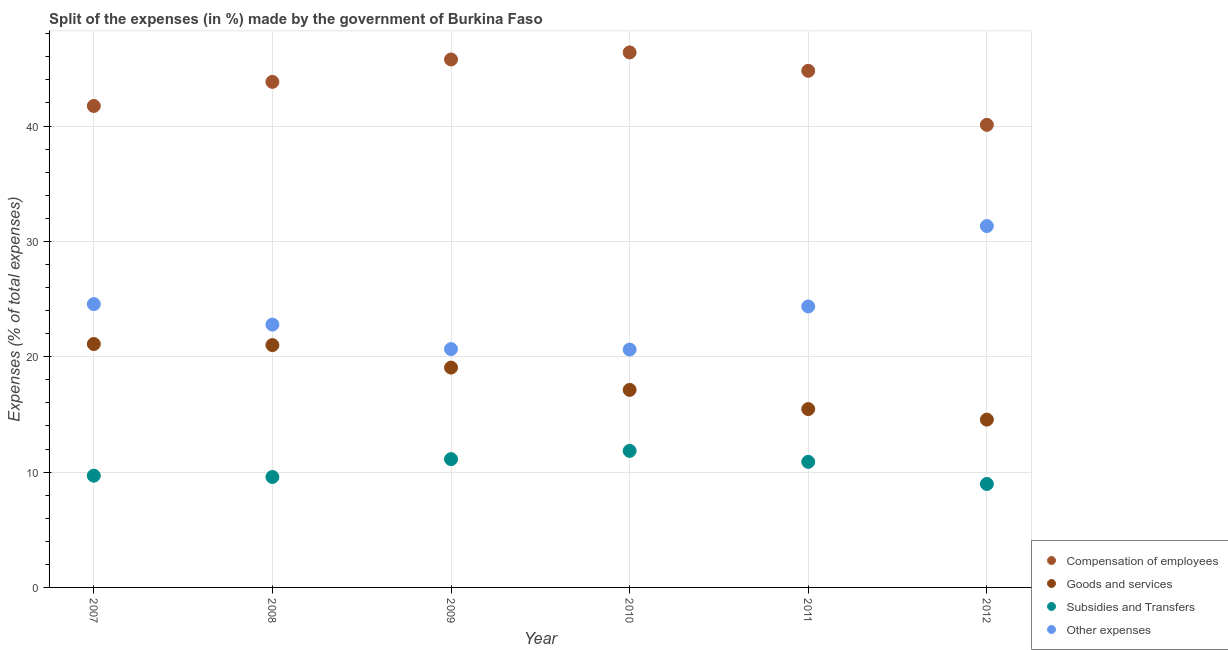Is the number of dotlines equal to the number of legend labels?
Offer a terse response. Yes. What is the percentage of amount spent on subsidies in 2010?
Make the answer very short. 11.84. Across all years, what is the maximum percentage of amount spent on subsidies?
Offer a very short reply. 11.84. Across all years, what is the minimum percentage of amount spent on other expenses?
Offer a terse response. 20.62. What is the total percentage of amount spent on goods and services in the graph?
Offer a very short reply. 108.31. What is the difference between the percentage of amount spent on subsidies in 2007 and that in 2012?
Provide a succinct answer. 0.72. What is the difference between the percentage of amount spent on compensation of employees in 2011 and the percentage of amount spent on goods and services in 2012?
Ensure brevity in your answer.  30.24. What is the average percentage of amount spent on compensation of employees per year?
Give a very brief answer. 43.77. In the year 2010, what is the difference between the percentage of amount spent on other expenses and percentage of amount spent on goods and services?
Offer a very short reply. 3.49. What is the ratio of the percentage of amount spent on goods and services in 2010 to that in 2011?
Give a very brief answer. 1.11. Is the percentage of amount spent on other expenses in 2007 less than that in 2010?
Your response must be concise. No. Is the difference between the percentage of amount spent on compensation of employees in 2008 and 2010 greater than the difference between the percentage of amount spent on goods and services in 2008 and 2010?
Make the answer very short. No. What is the difference between the highest and the second highest percentage of amount spent on other expenses?
Provide a succinct answer. 6.77. What is the difference between the highest and the lowest percentage of amount spent on goods and services?
Your answer should be compact. 6.55. In how many years, is the percentage of amount spent on other expenses greater than the average percentage of amount spent on other expenses taken over all years?
Your answer should be compact. 3. Is it the case that in every year, the sum of the percentage of amount spent on goods and services and percentage of amount spent on subsidies is greater than the sum of percentage of amount spent on other expenses and percentage of amount spent on compensation of employees?
Keep it short and to the point. No. Does the percentage of amount spent on compensation of employees monotonically increase over the years?
Your response must be concise. No. Is the percentage of amount spent on other expenses strictly less than the percentage of amount spent on subsidies over the years?
Give a very brief answer. No. How many years are there in the graph?
Provide a short and direct response. 6. What is the difference between two consecutive major ticks on the Y-axis?
Your answer should be very brief. 10. Does the graph contain any zero values?
Provide a short and direct response. No. Does the graph contain grids?
Offer a very short reply. Yes. How are the legend labels stacked?
Offer a very short reply. Vertical. What is the title of the graph?
Make the answer very short. Split of the expenses (in %) made by the government of Burkina Faso. Does "Finland" appear as one of the legend labels in the graph?
Give a very brief answer. No. What is the label or title of the Y-axis?
Your answer should be compact. Expenses (% of total expenses). What is the Expenses (% of total expenses) in Compensation of employees in 2007?
Ensure brevity in your answer.  41.74. What is the Expenses (% of total expenses) in Goods and services in 2007?
Offer a terse response. 21.1. What is the Expenses (% of total expenses) in Subsidies and Transfers in 2007?
Provide a short and direct response. 9.69. What is the Expenses (% of total expenses) in Other expenses in 2007?
Provide a short and direct response. 24.56. What is the Expenses (% of total expenses) of Compensation of employees in 2008?
Give a very brief answer. 43.83. What is the Expenses (% of total expenses) of Goods and services in 2008?
Make the answer very short. 21.01. What is the Expenses (% of total expenses) of Subsidies and Transfers in 2008?
Your response must be concise. 9.57. What is the Expenses (% of total expenses) of Other expenses in 2008?
Provide a short and direct response. 22.79. What is the Expenses (% of total expenses) in Compensation of employees in 2009?
Offer a very short reply. 45.77. What is the Expenses (% of total expenses) in Goods and services in 2009?
Offer a very short reply. 19.06. What is the Expenses (% of total expenses) of Subsidies and Transfers in 2009?
Make the answer very short. 11.12. What is the Expenses (% of total expenses) of Other expenses in 2009?
Your answer should be very brief. 20.66. What is the Expenses (% of total expenses) of Compensation of employees in 2010?
Your answer should be very brief. 46.38. What is the Expenses (% of total expenses) of Goods and services in 2010?
Ensure brevity in your answer.  17.13. What is the Expenses (% of total expenses) of Subsidies and Transfers in 2010?
Offer a very short reply. 11.84. What is the Expenses (% of total expenses) of Other expenses in 2010?
Make the answer very short. 20.62. What is the Expenses (% of total expenses) in Compensation of employees in 2011?
Give a very brief answer. 44.79. What is the Expenses (% of total expenses) in Goods and services in 2011?
Provide a succinct answer. 15.46. What is the Expenses (% of total expenses) in Subsidies and Transfers in 2011?
Your answer should be very brief. 10.89. What is the Expenses (% of total expenses) of Other expenses in 2011?
Your answer should be very brief. 24.36. What is the Expenses (% of total expenses) of Compensation of employees in 2012?
Offer a terse response. 40.11. What is the Expenses (% of total expenses) of Goods and services in 2012?
Provide a short and direct response. 14.55. What is the Expenses (% of total expenses) of Subsidies and Transfers in 2012?
Give a very brief answer. 8.97. What is the Expenses (% of total expenses) in Other expenses in 2012?
Give a very brief answer. 31.33. Across all years, what is the maximum Expenses (% of total expenses) in Compensation of employees?
Keep it short and to the point. 46.38. Across all years, what is the maximum Expenses (% of total expenses) of Goods and services?
Make the answer very short. 21.1. Across all years, what is the maximum Expenses (% of total expenses) in Subsidies and Transfers?
Give a very brief answer. 11.84. Across all years, what is the maximum Expenses (% of total expenses) of Other expenses?
Provide a short and direct response. 31.33. Across all years, what is the minimum Expenses (% of total expenses) in Compensation of employees?
Provide a succinct answer. 40.11. Across all years, what is the minimum Expenses (% of total expenses) of Goods and services?
Make the answer very short. 14.55. Across all years, what is the minimum Expenses (% of total expenses) in Subsidies and Transfers?
Give a very brief answer. 8.97. Across all years, what is the minimum Expenses (% of total expenses) of Other expenses?
Offer a terse response. 20.62. What is the total Expenses (% of total expenses) of Compensation of employees in the graph?
Offer a very short reply. 262.62. What is the total Expenses (% of total expenses) of Goods and services in the graph?
Provide a short and direct response. 108.31. What is the total Expenses (% of total expenses) in Subsidies and Transfers in the graph?
Offer a very short reply. 62.08. What is the total Expenses (% of total expenses) of Other expenses in the graph?
Give a very brief answer. 144.32. What is the difference between the Expenses (% of total expenses) of Compensation of employees in 2007 and that in 2008?
Keep it short and to the point. -2.09. What is the difference between the Expenses (% of total expenses) in Goods and services in 2007 and that in 2008?
Give a very brief answer. 0.09. What is the difference between the Expenses (% of total expenses) in Subsidies and Transfers in 2007 and that in 2008?
Your answer should be very brief. 0.11. What is the difference between the Expenses (% of total expenses) in Other expenses in 2007 and that in 2008?
Ensure brevity in your answer.  1.77. What is the difference between the Expenses (% of total expenses) in Compensation of employees in 2007 and that in 2009?
Give a very brief answer. -4.03. What is the difference between the Expenses (% of total expenses) in Goods and services in 2007 and that in 2009?
Make the answer very short. 2.04. What is the difference between the Expenses (% of total expenses) in Subsidies and Transfers in 2007 and that in 2009?
Your answer should be very brief. -1.43. What is the difference between the Expenses (% of total expenses) of Other expenses in 2007 and that in 2009?
Keep it short and to the point. 3.9. What is the difference between the Expenses (% of total expenses) of Compensation of employees in 2007 and that in 2010?
Keep it short and to the point. -4.64. What is the difference between the Expenses (% of total expenses) in Goods and services in 2007 and that in 2010?
Offer a very short reply. 3.98. What is the difference between the Expenses (% of total expenses) of Subsidies and Transfers in 2007 and that in 2010?
Your answer should be compact. -2.15. What is the difference between the Expenses (% of total expenses) of Other expenses in 2007 and that in 2010?
Make the answer very short. 3.94. What is the difference between the Expenses (% of total expenses) of Compensation of employees in 2007 and that in 2011?
Your answer should be compact. -3.05. What is the difference between the Expenses (% of total expenses) of Goods and services in 2007 and that in 2011?
Offer a very short reply. 5.64. What is the difference between the Expenses (% of total expenses) in Subsidies and Transfers in 2007 and that in 2011?
Your answer should be very brief. -1.2. What is the difference between the Expenses (% of total expenses) of Other expenses in 2007 and that in 2011?
Offer a terse response. 0.2. What is the difference between the Expenses (% of total expenses) of Compensation of employees in 2007 and that in 2012?
Your answer should be compact. 1.64. What is the difference between the Expenses (% of total expenses) in Goods and services in 2007 and that in 2012?
Your answer should be compact. 6.55. What is the difference between the Expenses (% of total expenses) in Subsidies and Transfers in 2007 and that in 2012?
Provide a short and direct response. 0.72. What is the difference between the Expenses (% of total expenses) of Other expenses in 2007 and that in 2012?
Offer a very short reply. -6.77. What is the difference between the Expenses (% of total expenses) of Compensation of employees in 2008 and that in 2009?
Your answer should be very brief. -1.94. What is the difference between the Expenses (% of total expenses) of Goods and services in 2008 and that in 2009?
Offer a terse response. 1.95. What is the difference between the Expenses (% of total expenses) of Subsidies and Transfers in 2008 and that in 2009?
Your answer should be very brief. -1.55. What is the difference between the Expenses (% of total expenses) of Other expenses in 2008 and that in 2009?
Keep it short and to the point. 2.12. What is the difference between the Expenses (% of total expenses) of Compensation of employees in 2008 and that in 2010?
Your answer should be compact. -2.55. What is the difference between the Expenses (% of total expenses) of Goods and services in 2008 and that in 2010?
Make the answer very short. 3.88. What is the difference between the Expenses (% of total expenses) in Subsidies and Transfers in 2008 and that in 2010?
Ensure brevity in your answer.  -2.26. What is the difference between the Expenses (% of total expenses) in Other expenses in 2008 and that in 2010?
Ensure brevity in your answer.  2.17. What is the difference between the Expenses (% of total expenses) of Compensation of employees in 2008 and that in 2011?
Your answer should be very brief. -0.96. What is the difference between the Expenses (% of total expenses) in Goods and services in 2008 and that in 2011?
Ensure brevity in your answer.  5.55. What is the difference between the Expenses (% of total expenses) of Subsidies and Transfers in 2008 and that in 2011?
Your answer should be very brief. -1.31. What is the difference between the Expenses (% of total expenses) of Other expenses in 2008 and that in 2011?
Provide a short and direct response. -1.57. What is the difference between the Expenses (% of total expenses) in Compensation of employees in 2008 and that in 2012?
Provide a succinct answer. 3.72. What is the difference between the Expenses (% of total expenses) in Goods and services in 2008 and that in 2012?
Your answer should be very brief. 6.46. What is the difference between the Expenses (% of total expenses) of Subsidies and Transfers in 2008 and that in 2012?
Your answer should be very brief. 0.61. What is the difference between the Expenses (% of total expenses) of Other expenses in 2008 and that in 2012?
Your answer should be very brief. -8.54. What is the difference between the Expenses (% of total expenses) in Compensation of employees in 2009 and that in 2010?
Your answer should be very brief. -0.61. What is the difference between the Expenses (% of total expenses) of Goods and services in 2009 and that in 2010?
Offer a very short reply. 1.93. What is the difference between the Expenses (% of total expenses) in Subsidies and Transfers in 2009 and that in 2010?
Your answer should be compact. -0.71. What is the difference between the Expenses (% of total expenses) in Other expenses in 2009 and that in 2010?
Ensure brevity in your answer.  0.04. What is the difference between the Expenses (% of total expenses) in Compensation of employees in 2009 and that in 2011?
Provide a succinct answer. 0.98. What is the difference between the Expenses (% of total expenses) of Goods and services in 2009 and that in 2011?
Ensure brevity in your answer.  3.6. What is the difference between the Expenses (% of total expenses) in Subsidies and Transfers in 2009 and that in 2011?
Give a very brief answer. 0.24. What is the difference between the Expenses (% of total expenses) in Other expenses in 2009 and that in 2011?
Ensure brevity in your answer.  -3.69. What is the difference between the Expenses (% of total expenses) of Compensation of employees in 2009 and that in 2012?
Offer a very short reply. 5.67. What is the difference between the Expenses (% of total expenses) of Goods and services in 2009 and that in 2012?
Provide a succinct answer. 4.51. What is the difference between the Expenses (% of total expenses) in Subsidies and Transfers in 2009 and that in 2012?
Provide a short and direct response. 2.15. What is the difference between the Expenses (% of total expenses) of Other expenses in 2009 and that in 2012?
Keep it short and to the point. -10.67. What is the difference between the Expenses (% of total expenses) of Compensation of employees in 2010 and that in 2011?
Provide a short and direct response. 1.6. What is the difference between the Expenses (% of total expenses) of Goods and services in 2010 and that in 2011?
Keep it short and to the point. 1.66. What is the difference between the Expenses (% of total expenses) of Subsidies and Transfers in 2010 and that in 2011?
Your answer should be very brief. 0.95. What is the difference between the Expenses (% of total expenses) in Other expenses in 2010 and that in 2011?
Provide a succinct answer. -3.74. What is the difference between the Expenses (% of total expenses) in Compensation of employees in 2010 and that in 2012?
Keep it short and to the point. 6.28. What is the difference between the Expenses (% of total expenses) in Goods and services in 2010 and that in 2012?
Your answer should be very brief. 2.58. What is the difference between the Expenses (% of total expenses) in Subsidies and Transfers in 2010 and that in 2012?
Keep it short and to the point. 2.87. What is the difference between the Expenses (% of total expenses) in Other expenses in 2010 and that in 2012?
Keep it short and to the point. -10.71. What is the difference between the Expenses (% of total expenses) in Compensation of employees in 2011 and that in 2012?
Give a very brief answer. 4.68. What is the difference between the Expenses (% of total expenses) in Goods and services in 2011 and that in 2012?
Offer a terse response. 0.91. What is the difference between the Expenses (% of total expenses) in Subsidies and Transfers in 2011 and that in 2012?
Ensure brevity in your answer.  1.92. What is the difference between the Expenses (% of total expenses) of Other expenses in 2011 and that in 2012?
Offer a very short reply. -6.97. What is the difference between the Expenses (% of total expenses) in Compensation of employees in 2007 and the Expenses (% of total expenses) in Goods and services in 2008?
Provide a succinct answer. 20.73. What is the difference between the Expenses (% of total expenses) of Compensation of employees in 2007 and the Expenses (% of total expenses) of Subsidies and Transfers in 2008?
Provide a succinct answer. 32.17. What is the difference between the Expenses (% of total expenses) in Compensation of employees in 2007 and the Expenses (% of total expenses) in Other expenses in 2008?
Offer a terse response. 18.95. What is the difference between the Expenses (% of total expenses) in Goods and services in 2007 and the Expenses (% of total expenses) in Subsidies and Transfers in 2008?
Your answer should be very brief. 11.53. What is the difference between the Expenses (% of total expenses) in Goods and services in 2007 and the Expenses (% of total expenses) in Other expenses in 2008?
Provide a succinct answer. -1.69. What is the difference between the Expenses (% of total expenses) of Subsidies and Transfers in 2007 and the Expenses (% of total expenses) of Other expenses in 2008?
Offer a terse response. -13.1. What is the difference between the Expenses (% of total expenses) in Compensation of employees in 2007 and the Expenses (% of total expenses) in Goods and services in 2009?
Your answer should be compact. 22.68. What is the difference between the Expenses (% of total expenses) of Compensation of employees in 2007 and the Expenses (% of total expenses) of Subsidies and Transfers in 2009?
Make the answer very short. 30.62. What is the difference between the Expenses (% of total expenses) in Compensation of employees in 2007 and the Expenses (% of total expenses) in Other expenses in 2009?
Ensure brevity in your answer.  21.08. What is the difference between the Expenses (% of total expenses) in Goods and services in 2007 and the Expenses (% of total expenses) in Subsidies and Transfers in 2009?
Make the answer very short. 9.98. What is the difference between the Expenses (% of total expenses) of Goods and services in 2007 and the Expenses (% of total expenses) of Other expenses in 2009?
Make the answer very short. 0.44. What is the difference between the Expenses (% of total expenses) of Subsidies and Transfers in 2007 and the Expenses (% of total expenses) of Other expenses in 2009?
Provide a succinct answer. -10.98. What is the difference between the Expenses (% of total expenses) in Compensation of employees in 2007 and the Expenses (% of total expenses) in Goods and services in 2010?
Offer a terse response. 24.62. What is the difference between the Expenses (% of total expenses) of Compensation of employees in 2007 and the Expenses (% of total expenses) of Subsidies and Transfers in 2010?
Your response must be concise. 29.9. What is the difference between the Expenses (% of total expenses) in Compensation of employees in 2007 and the Expenses (% of total expenses) in Other expenses in 2010?
Keep it short and to the point. 21.12. What is the difference between the Expenses (% of total expenses) of Goods and services in 2007 and the Expenses (% of total expenses) of Subsidies and Transfers in 2010?
Your response must be concise. 9.26. What is the difference between the Expenses (% of total expenses) of Goods and services in 2007 and the Expenses (% of total expenses) of Other expenses in 2010?
Provide a succinct answer. 0.48. What is the difference between the Expenses (% of total expenses) in Subsidies and Transfers in 2007 and the Expenses (% of total expenses) in Other expenses in 2010?
Give a very brief answer. -10.93. What is the difference between the Expenses (% of total expenses) of Compensation of employees in 2007 and the Expenses (% of total expenses) of Goods and services in 2011?
Your response must be concise. 26.28. What is the difference between the Expenses (% of total expenses) in Compensation of employees in 2007 and the Expenses (% of total expenses) in Subsidies and Transfers in 2011?
Provide a succinct answer. 30.86. What is the difference between the Expenses (% of total expenses) in Compensation of employees in 2007 and the Expenses (% of total expenses) in Other expenses in 2011?
Your answer should be compact. 17.38. What is the difference between the Expenses (% of total expenses) in Goods and services in 2007 and the Expenses (% of total expenses) in Subsidies and Transfers in 2011?
Ensure brevity in your answer.  10.22. What is the difference between the Expenses (% of total expenses) of Goods and services in 2007 and the Expenses (% of total expenses) of Other expenses in 2011?
Offer a terse response. -3.26. What is the difference between the Expenses (% of total expenses) in Subsidies and Transfers in 2007 and the Expenses (% of total expenses) in Other expenses in 2011?
Give a very brief answer. -14.67. What is the difference between the Expenses (% of total expenses) of Compensation of employees in 2007 and the Expenses (% of total expenses) of Goods and services in 2012?
Offer a terse response. 27.19. What is the difference between the Expenses (% of total expenses) in Compensation of employees in 2007 and the Expenses (% of total expenses) in Subsidies and Transfers in 2012?
Ensure brevity in your answer.  32.77. What is the difference between the Expenses (% of total expenses) of Compensation of employees in 2007 and the Expenses (% of total expenses) of Other expenses in 2012?
Your answer should be compact. 10.41. What is the difference between the Expenses (% of total expenses) of Goods and services in 2007 and the Expenses (% of total expenses) of Subsidies and Transfers in 2012?
Make the answer very short. 12.13. What is the difference between the Expenses (% of total expenses) in Goods and services in 2007 and the Expenses (% of total expenses) in Other expenses in 2012?
Provide a succinct answer. -10.23. What is the difference between the Expenses (% of total expenses) of Subsidies and Transfers in 2007 and the Expenses (% of total expenses) of Other expenses in 2012?
Ensure brevity in your answer.  -21.64. What is the difference between the Expenses (% of total expenses) in Compensation of employees in 2008 and the Expenses (% of total expenses) in Goods and services in 2009?
Offer a terse response. 24.77. What is the difference between the Expenses (% of total expenses) in Compensation of employees in 2008 and the Expenses (% of total expenses) in Subsidies and Transfers in 2009?
Provide a succinct answer. 32.71. What is the difference between the Expenses (% of total expenses) in Compensation of employees in 2008 and the Expenses (% of total expenses) in Other expenses in 2009?
Provide a succinct answer. 23.16. What is the difference between the Expenses (% of total expenses) in Goods and services in 2008 and the Expenses (% of total expenses) in Subsidies and Transfers in 2009?
Your answer should be compact. 9.89. What is the difference between the Expenses (% of total expenses) of Goods and services in 2008 and the Expenses (% of total expenses) of Other expenses in 2009?
Your response must be concise. 0.35. What is the difference between the Expenses (% of total expenses) of Subsidies and Transfers in 2008 and the Expenses (% of total expenses) of Other expenses in 2009?
Give a very brief answer. -11.09. What is the difference between the Expenses (% of total expenses) in Compensation of employees in 2008 and the Expenses (% of total expenses) in Goods and services in 2010?
Offer a very short reply. 26.7. What is the difference between the Expenses (% of total expenses) in Compensation of employees in 2008 and the Expenses (% of total expenses) in Subsidies and Transfers in 2010?
Give a very brief answer. 31.99. What is the difference between the Expenses (% of total expenses) of Compensation of employees in 2008 and the Expenses (% of total expenses) of Other expenses in 2010?
Make the answer very short. 23.21. What is the difference between the Expenses (% of total expenses) of Goods and services in 2008 and the Expenses (% of total expenses) of Subsidies and Transfers in 2010?
Provide a succinct answer. 9.17. What is the difference between the Expenses (% of total expenses) of Goods and services in 2008 and the Expenses (% of total expenses) of Other expenses in 2010?
Your response must be concise. 0.39. What is the difference between the Expenses (% of total expenses) in Subsidies and Transfers in 2008 and the Expenses (% of total expenses) in Other expenses in 2010?
Give a very brief answer. -11.05. What is the difference between the Expenses (% of total expenses) of Compensation of employees in 2008 and the Expenses (% of total expenses) of Goods and services in 2011?
Make the answer very short. 28.37. What is the difference between the Expenses (% of total expenses) in Compensation of employees in 2008 and the Expenses (% of total expenses) in Subsidies and Transfers in 2011?
Keep it short and to the point. 32.94. What is the difference between the Expenses (% of total expenses) of Compensation of employees in 2008 and the Expenses (% of total expenses) of Other expenses in 2011?
Give a very brief answer. 19.47. What is the difference between the Expenses (% of total expenses) in Goods and services in 2008 and the Expenses (% of total expenses) in Subsidies and Transfers in 2011?
Provide a succinct answer. 10.12. What is the difference between the Expenses (% of total expenses) of Goods and services in 2008 and the Expenses (% of total expenses) of Other expenses in 2011?
Make the answer very short. -3.35. What is the difference between the Expenses (% of total expenses) of Subsidies and Transfers in 2008 and the Expenses (% of total expenses) of Other expenses in 2011?
Your answer should be very brief. -14.78. What is the difference between the Expenses (% of total expenses) in Compensation of employees in 2008 and the Expenses (% of total expenses) in Goods and services in 2012?
Offer a terse response. 29.28. What is the difference between the Expenses (% of total expenses) of Compensation of employees in 2008 and the Expenses (% of total expenses) of Subsidies and Transfers in 2012?
Give a very brief answer. 34.86. What is the difference between the Expenses (% of total expenses) in Compensation of employees in 2008 and the Expenses (% of total expenses) in Other expenses in 2012?
Ensure brevity in your answer.  12.5. What is the difference between the Expenses (% of total expenses) in Goods and services in 2008 and the Expenses (% of total expenses) in Subsidies and Transfers in 2012?
Make the answer very short. 12.04. What is the difference between the Expenses (% of total expenses) in Goods and services in 2008 and the Expenses (% of total expenses) in Other expenses in 2012?
Offer a terse response. -10.32. What is the difference between the Expenses (% of total expenses) of Subsidies and Transfers in 2008 and the Expenses (% of total expenses) of Other expenses in 2012?
Make the answer very short. -21.76. What is the difference between the Expenses (% of total expenses) in Compensation of employees in 2009 and the Expenses (% of total expenses) in Goods and services in 2010?
Your answer should be compact. 28.65. What is the difference between the Expenses (% of total expenses) in Compensation of employees in 2009 and the Expenses (% of total expenses) in Subsidies and Transfers in 2010?
Ensure brevity in your answer.  33.93. What is the difference between the Expenses (% of total expenses) in Compensation of employees in 2009 and the Expenses (% of total expenses) in Other expenses in 2010?
Your response must be concise. 25.15. What is the difference between the Expenses (% of total expenses) in Goods and services in 2009 and the Expenses (% of total expenses) in Subsidies and Transfers in 2010?
Provide a succinct answer. 7.22. What is the difference between the Expenses (% of total expenses) of Goods and services in 2009 and the Expenses (% of total expenses) of Other expenses in 2010?
Keep it short and to the point. -1.56. What is the difference between the Expenses (% of total expenses) in Subsidies and Transfers in 2009 and the Expenses (% of total expenses) in Other expenses in 2010?
Offer a terse response. -9.5. What is the difference between the Expenses (% of total expenses) in Compensation of employees in 2009 and the Expenses (% of total expenses) in Goods and services in 2011?
Keep it short and to the point. 30.31. What is the difference between the Expenses (% of total expenses) in Compensation of employees in 2009 and the Expenses (% of total expenses) in Subsidies and Transfers in 2011?
Keep it short and to the point. 34.89. What is the difference between the Expenses (% of total expenses) in Compensation of employees in 2009 and the Expenses (% of total expenses) in Other expenses in 2011?
Make the answer very short. 21.41. What is the difference between the Expenses (% of total expenses) of Goods and services in 2009 and the Expenses (% of total expenses) of Subsidies and Transfers in 2011?
Provide a short and direct response. 8.17. What is the difference between the Expenses (% of total expenses) in Goods and services in 2009 and the Expenses (% of total expenses) in Other expenses in 2011?
Provide a succinct answer. -5.3. What is the difference between the Expenses (% of total expenses) in Subsidies and Transfers in 2009 and the Expenses (% of total expenses) in Other expenses in 2011?
Your response must be concise. -13.24. What is the difference between the Expenses (% of total expenses) of Compensation of employees in 2009 and the Expenses (% of total expenses) of Goods and services in 2012?
Ensure brevity in your answer.  31.22. What is the difference between the Expenses (% of total expenses) in Compensation of employees in 2009 and the Expenses (% of total expenses) in Subsidies and Transfers in 2012?
Give a very brief answer. 36.8. What is the difference between the Expenses (% of total expenses) of Compensation of employees in 2009 and the Expenses (% of total expenses) of Other expenses in 2012?
Offer a terse response. 14.44. What is the difference between the Expenses (% of total expenses) of Goods and services in 2009 and the Expenses (% of total expenses) of Subsidies and Transfers in 2012?
Provide a succinct answer. 10.09. What is the difference between the Expenses (% of total expenses) in Goods and services in 2009 and the Expenses (% of total expenses) in Other expenses in 2012?
Make the answer very short. -12.27. What is the difference between the Expenses (% of total expenses) of Subsidies and Transfers in 2009 and the Expenses (% of total expenses) of Other expenses in 2012?
Keep it short and to the point. -20.21. What is the difference between the Expenses (% of total expenses) of Compensation of employees in 2010 and the Expenses (% of total expenses) of Goods and services in 2011?
Make the answer very short. 30.92. What is the difference between the Expenses (% of total expenses) of Compensation of employees in 2010 and the Expenses (% of total expenses) of Subsidies and Transfers in 2011?
Provide a short and direct response. 35.5. What is the difference between the Expenses (% of total expenses) in Compensation of employees in 2010 and the Expenses (% of total expenses) in Other expenses in 2011?
Your answer should be very brief. 22.03. What is the difference between the Expenses (% of total expenses) of Goods and services in 2010 and the Expenses (% of total expenses) of Subsidies and Transfers in 2011?
Your answer should be very brief. 6.24. What is the difference between the Expenses (% of total expenses) of Goods and services in 2010 and the Expenses (% of total expenses) of Other expenses in 2011?
Give a very brief answer. -7.23. What is the difference between the Expenses (% of total expenses) of Subsidies and Transfers in 2010 and the Expenses (% of total expenses) of Other expenses in 2011?
Keep it short and to the point. -12.52. What is the difference between the Expenses (% of total expenses) of Compensation of employees in 2010 and the Expenses (% of total expenses) of Goods and services in 2012?
Make the answer very short. 31.83. What is the difference between the Expenses (% of total expenses) in Compensation of employees in 2010 and the Expenses (% of total expenses) in Subsidies and Transfers in 2012?
Provide a short and direct response. 37.42. What is the difference between the Expenses (% of total expenses) in Compensation of employees in 2010 and the Expenses (% of total expenses) in Other expenses in 2012?
Your response must be concise. 15.05. What is the difference between the Expenses (% of total expenses) of Goods and services in 2010 and the Expenses (% of total expenses) of Subsidies and Transfers in 2012?
Keep it short and to the point. 8.16. What is the difference between the Expenses (% of total expenses) in Goods and services in 2010 and the Expenses (% of total expenses) in Other expenses in 2012?
Offer a terse response. -14.2. What is the difference between the Expenses (% of total expenses) in Subsidies and Transfers in 2010 and the Expenses (% of total expenses) in Other expenses in 2012?
Offer a terse response. -19.49. What is the difference between the Expenses (% of total expenses) in Compensation of employees in 2011 and the Expenses (% of total expenses) in Goods and services in 2012?
Your answer should be compact. 30.24. What is the difference between the Expenses (% of total expenses) in Compensation of employees in 2011 and the Expenses (% of total expenses) in Subsidies and Transfers in 2012?
Offer a very short reply. 35.82. What is the difference between the Expenses (% of total expenses) of Compensation of employees in 2011 and the Expenses (% of total expenses) of Other expenses in 2012?
Provide a succinct answer. 13.46. What is the difference between the Expenses (% of total expenses) of Goods and services in 2011 and the Expenses (% of total expenses) of Subsidies and Transfers in 2012?
Keep it short and to the point. 6.49. What is the difference between the Expenses (% of total expenses) in Goods and services in 2011 and the Expenses (% of total expenses) in Other expenses in 2012?
Your response must be concise. -15.87. What is the difference between the Expenses (% of total expenses) in Subsidies and Transfers in 2011 and the Expenses (% of total expenses) in Other expenses in 2012?
Ensure brevity in your answer.  -20.44. What is the average Expenses (% of total expenses) in Compensation of employees per year?
Provide a succinct answer. 43.77. What is the average Expenses (% of total expenses) of Goods and services per year?
Give a very brief answer. 18.05. What is the average Expenses (% of total expenses) in Subsidies and Transfers per year?
Keep it short and to the point. 10.35. What is the average Expenses (% of total expenses) in Other expenses per year?
Provide a succinct answer. 24.05. In the year 2007, what is the difference between the Expenses (% of total expenses) of Compensation of employees and Expenses (% of total expenses) of Goods and services?
Your answer should be compact. 20.64. In the year 2007, what is the difference between the Expenses (% of total expenses) of Compensation of employees and Expenses (% of total expenses) of Subsidies and Transfers?
Make the answer very short. 32.05. In the year 2007, what is the difference between the Expenses (% of total expenses) in Compensation of employees and Expenses (% of total expenses) in Other expenses?
Your answer should be compact. 17.18. In the year 2007, what is the difference between the Expenses (% of total expenses) in Goods and services and Expenses (% of total expenses) in Subsidies and Transfers?
Give a very brief answer. 11.41. In the year 2007, what is the difference between the Expenses (% of total expenses) in Goods and services and Expenses (% of total expenses) in Other expenses?
Provide a short and direct response. -3.46. In the year 2007, what is the difference between the Expenses (% of total expenses) of Subsidies and Transfers and Expenses (% of total expenses) of Other expenses?
Your answer should be very brief. -14.87. In the year 2008, what is the difference between the Expenses (% of total expenses) of Compensation of employees and Expenses (% of total expenses) of Goods and services?
Keep it short and to the point. 22.82. In the year 2008, what is the difference between the Expenses (% of total expenses) of Compensation of employees and Expenses (% of total expenses) of Subsidies and Transfers?
Your answer should be compact. 34.26. In the year 2008, what is the difference between the Expenses (% of total expenses) of Compensation of employees and Expenses (% of total expenses) of Other expenses?
Keep it short and to the point. 21.04. In the year 2008, what is the difference between the Expenses (% of total expenses) in Goods and services and Expenses (% of total expenses) in Subsidies and Transfers?
Your answer should be compact. 11.44. In the year 2008, what is the difference between the Expenses (% of total expenses) in Goods and services and Expenses (% of total expenses) in Other expenses?
Provide a succinct answer. -1.78. In the year 2008, what is the difference between the Expenses (% of total expenses) of Subsidies and Transfers and Expenses (% of total expenses) of Other expenses?
Offer a terse response. -13.21. In the year 2009, what is the difference between the Expenses (% of total expenses) in Compensation of employees and Expenses (% of total expenses) in Goods and services?
Give a very brief answer. 26.71. In the year 2009, what is the difference between the Expenses (% of total expenses) in Compensation of employees and Expenses (% of total expenses) in Subsidies and Transfers?
Offer a terse response. 34.65. In the year 2009, what is the difference between the Expenses (% of total expenses) of Compensation of employees and Expenses (% of total expenses) of Other expenses?
Give a very brief answer. 25.11. In the year 2009, what is the difference between the Expenses (% of total expenses) in Goods and services and Expenses (% of total expenses) in Subsidies and Transfers?
Your answer should be compact. 7.94. In the year 2009, what is the difference between the Expenses (% of total expenses) of Goods and services and Expenses (% of total expenses) of Other expenses?
Ensure brevity in your answer.  -1.61. In the year 2009, what is the difference between the Expenses (% of total expenses) of Subsidies and Transfers and Expenses (% of total expenses) of Other expenses?
Give a very brief answer. -9.54. In the year 2010, what is the difference between the Expenses (% of total expenses) of Compensation of employees and Expenses (% of total expenses) of Goods and services?
Provide a succinct answer. 29.26. In the year 2010, what is the difference between the Expenses (% of total expenses) of Compensation of employees and Expenses (% of total expenses) of Subsidies and Transfers?
Your response must be concise. 34.55. In the year 2010, what is the difference between the Expenses (% of total expenses) of Compensation of employees and Expenses (% of total expenses) of Other expenses?
Your answer should be compact. 25.76. In the year 2010, what is the difference between the Expenses (% of total expenses) in Goods and services and Expenses (% of total expenses) in Subsidies and Transfers?
Make the answer very short. 5.29. In the year 2010, what is the difference between the Expenses (% of total expenses) of Goods and services and Expenses (% of total expenses) of Other expenses?
Give a very brief answer. -3.49. In the year 2010, what is the difference between the Expenses (% of total expenses) of Subsidies and Transfers and Expenses (% of total expenses) of Other expenses?
Provide a short and direct response. -8.78. In the year 2011, what is the difference between the Expenses (% of total expenses) in Compensation of employees and Expenses (% of total expenses) in Goods and services?
Your answer should be very brief. 29.33. In the year 2011, what is the difference between the Expenses (% of total expenses) of Compensation of employees and Expenses (% of total expenses) of Subsidies and Transfers?
Your answer should be compact. 33.9. In the year 2011, what is the difference between the Expenses (% of total expenses) in Compensation of employees and Expenses (% of total expenses) in Other expenses?
Give a very brief answer. 20.43. In the year 2011, what is the difference between the Expenses (% of total expenses) of Goods and services and Expenses (% of total expenses) of Subsidies and Transfers?
Offer a terse response. 4.58. In the year 2011, what is the difference between the Expenses (% of total expenses) in Goods and services and Expenses (% of total expenses) in Other expenses?
Give a very brief answer. -8.9. In the year 2011, what is the difference between the Expenses (% of total expenses) of Subsidies and Transfers and Expenses (% of total expenses) of Other expenses?
Make the answer very short. -13.47. In the year 2012, what is the difference between the Expenses (% of total expenses) in Compensation of employees and Expenses (% of total expenses) in Goods and services?
Give a very brief answer. 25.56. In the year 2012, what is the difference between the Expenses (% of total expenses) of Compensation of employees and Expenses (% of total expenses) of Subsidies and Transfers?
Provide a short and direct response. 31.14. In the year 2012, what is the difference between the Expenses (% of total expenses) in Compensation of employees and Expenses (% of total expenses) in Other expenses?
Ensure brevity in your answer.  8.77. In the year 2012, what is the difference between the Expenses (% of total expenses) of Goods and services and Expenses (% of total expenses) of Subsidies and Transfers?
Your answer should be very brief. 5.58. In the year 2012, what is the difference between the Expenses (% of total expenses) of Goods and services and Expenses (% of total expenses) of Other expenses?
Provide a short and direct response. -16.78. In the year 2012, what is the difference between the Expenses (% of total expenses) in Subsidies and Transfers and Expenses (% of total expenses) in Other expenses?
Your response must be concise. -22.36. What is the ratio of the Expenses (% of total expenses) of Goods and services in 2007 to that in 2008?
Offer a very short reply. 1. What is the ratio of the Expenses (% of total expenses) in Other expenses in 2007 to that in 2008?
Provide a short and direct response. 1.08. What is the ratio of the Expenses (% of total expenses) of Compensation of employees in 2007 to that in 2009?
Your answer should be very brief. 0.91. What is the ratio of the Expenses (% of total expenses) of Goods and services in 2007 to that in 2009?
Give a very brief answer. 1.11. What is the ratio of the Expenses (% of total expenses) in Subsidies and Transfers in 2007 to that in 2009?
Offer a very short reply. 0.87. What is the ratio of the Expenses (% of total expenses) in Other expenses in 2007 to that in 2009?
Offer a very short reply. 1.19. What is the ratio of the Expenses (% of total expenses) in Compensation of employees in 2007 to that in 2010?
Your answer should be very brief. 0.9. What is the ratio of the Expenses (% of total expenses) of Goods and services in 2007 to that in 2010?
Provide a succinct answer. 1.23. What is the ratio of the Expenses (% of total expenses) of Subsidies and Transfers in 2007 to that in 2010?
Offer a terse response. 0.82. What is the ratio of the Expenses (% of total expenses) in Other expenses in 2007 to that in 2010?
Give a very brief answer. 1.19. What is the ratio of the Expenses (% of total expenses) of Compensation of employees in 2007 to that in 2011?
Your answer should be very brief. 0.93. What is the ratio of the Expenses (% of total expenses) of Goods and services in 2007 to that in 2011?
Provide a short and direct response. 1.36. What is the ratio of the Expenses (% of total expenses) of Subsidies and Transfers in 2007 to that in 2011?
Ensure brevity in your answer.  0.89. What is the ratio of the Expenses (% of total expenses) in Other expenses in 2007 to that in 2011?
Provide a succinct answer. 1.01. What is the ratio of the Expenses (% of total expenses) in Compensation of employees in 2007 to that in 2012?
Provide a succinct answer. 1.04. What is the ratio of the Expenses (% of total expenses) in Goods and services in 2007 to that in 2012?
Your answer should be very brief. 1.45. What is the ratio of the Expenses (% of total expenses) of Subsidies and Transfers in 2007 to that in 2012?
Your response must be concise. 1.08. What is the ratio of the Expenses (% of total expenses) of Other expenses in 2007 to that in 2012?
Your answer should be very brief. 0.78. What is the ratio of the Expenses (% of total expenses) of Compensation of employees in 2008 to that in 2009?
Provide a succinct answer. 0.96. What is the ratio of the Expenses (% of total expenses) of Goods and services in 2008 to that in 2009?
Provide a succinct answer. 1.1. What is the ratio of the Expenses (% of total expenses) in Subsidies and Transfers in 2008 to that in 2009?
Make the answer very short. 0.86. What is the ratio of the Expenses (% of total expenses) of Other expenses in 2008 to that in 2009?
Make the answer very short. 1.1. What is the ratio of the Expenses (% of total expenses) in Compensation of employees in 2008 to that in 2010?
Give a very brief answer. 0.94. What is the ratio of the Expenses (% of total expenses) in Goods and services in 2008 to that in 2010?
Your answer should be compact. 1.23. What is the ratio of the Expenses (% of total expenses) of Subsidies and Transfers in 2008 to that in 2010?
Your response must be concise. 0.81. What is the ratio of the Expenses (% of total expenses) of Other expenses in 2008 to that in 2010?
Your answer should be very brief. 1.11. What is the ratio of the Expenses (% of total expenses) in Compensation of employees in 2008 to that in 2011?
Make the answer very short. 0.98. What is the ratio of the Expenses (% of total expenses) of Goods and services in 2008 to that in 2011?
Offer a terse response. 1.36. What is the ratio of the Expenses (% of total expenses) of Subsidies and Transfers in 2008 to that in 2011?
Give a very brief answer. 0.88. What is the ratio of the Expenses (% of total expenses) of Other expenses in 2008 to that in 2011?
Offer a very short reply. 0.94. What is the ratio of the Expenses (% of total expenses) of Compensation of employees in 2008 to that in 2012?
Provide a succinct answer. 1.09. What is the ratio of the Expenses (% of total expenses) of Goods and services in 2008 to that in 2012?
Keep it short and to the point. 1.44. What is the ratio of the Expenses (% of total expenses) of Subsidies and Transfers in 2008 to that in 2012?
Provide a short and direct response. 1.07. What is the ratio of the Expenses (% of total expenses) in Other expenses in 2008 to that in 2012?
Give a very brief answer. 0.73. What is the ratio of the Expenses (% of total expenses) in Compensation of employees in 2009 to that in 2010?
Your response must be concise. 0.99. What is the ratio of the Expenses (% of total expenses) of Goods and services in 2009 to that in 2010?
Your response must be concise. 1.11. What is the ratio of the Expenses (% of total expenses) of Subsidies and Transfers in 2009 to that in 2010?
Offer a terse response. 0.94. What is the ratio of the Expenses (% of total expenses) of Other expenses in 2009 to that in 2010?
Your answer should be very brief. 1. What is the ratio of the Expenses (% of total expenses) of Goods and services in 2009 to that in 2011?
Make the answer very short. 1.23. What is the ratio of the Expenses (% of total expenses) in Subsidies and Transfers in 2009 to that in 2011?
Your response must be concise. 1.02. What is the ratio of the Expenses (% of total expenses) of Other expenses in 2009 to that in 2011?
Offer a terse response. 0.85. What is the ratio of the Expenses (% of total expenses) of Compensation of employees in 2009 to that in 2012?
Provide a succinct answer. 1.14. What is the ratio of the Expenses (% of total expenses) of Goods and services in 2009 to that in 2012?
Your response must be concise. 1.31. What is the ratio of the Expenses (% of total expenses) in Subsidies and Transfers in 2009 to that in 2012?
Offer a very short reply. 1.24. What is the ratio of the Expenses (% of total expenses) in Other expenses in 2009 to that in 2012?
Keep it short and to the point. 0.66. What is the ratio of the Expenses (% of total expenses) in Compensation of employees in 2010 to that in 2011?
Make the answer very short. 1.04. What is the ratio of the Expenses (% of total expenses) of Goods and services in 2010 to that in 2011?
Offer a terse response. 1.11. What is the ratio of the Expenses (% of total expenses) of Subsidies and Transfers in 2010 to that in 2011?
Provide a succinct answer. 1.09. What is the ratio of the Expenses (% of total expenses) of Other expenses in 2010 to that in 2011?
Give a very brief answer. 0.85. What is the ratio of the Expenses (% of total expenses) in Compensation of employees in 2010 to that in 2012?
Offer a very short reply. 1.16. What is the ratio of the Expenses (% of total expenses) of Goods and services in 2010 to that in 2012?
Your answer should be compact. 1.18. What is the ratio of the Expenses (% of total expenses) of Subsidies and Transfers in 2010 to that in 2012?
Make the answer very short. 1.32. What is the ratio of the Expenses (% of total expenses) of Other expenses in 2010 to that in 2012?
Your response must be concise. 0.66. What is the ratio of the Expenses (% of total expenses) in Compensation of employees in 2011 to that in 2012?
Make the answer very short. 1.12. What is the ratio of the Expenses (% of total expenses) in Goods and services in 2011 to that in 2012?
Your response must be concise. 1.06. What is the ratio of the Expenses (% of total expenses) in Subsidies and Transfers in 2011 to that in 2012?
Your answer should be very brief. 1.21. What is the ratio of the Expenses (% of total expenses) in Other expenses in 2011 to that in 2012?
Offer a terse response. 0.78. What is the difference between the highest and the second highest Expenses (% of total expenses) in Compensation of employees?
Offer a very short reply. 0.61. What is the difference between the highest and the second highest Expenses (% of total expenses) of Goods and services?
Your response must be concise. 0.09. What is the difference between the highest and the second highest Expenses (% of total expenses) in Subsidies and Transfers?
Offer a terse response. 0.71. What is the difference between the highest and the second highest Expenses (% of total expenses) in Other expenses?
Provide a short and direct response. 6.77. What is the difference between the highest and the lowest Expenses (% of total expenses) in Compensation of employees?
Give a very brief answer. 6.28. What is the difference between the highest and the lowest Expenses (% of total expenses) of Goods and services?
Provide a short and direct response. 6.55. What is the difference between the highest and the lowest Expenses (% of total expenses) in Subsidies and Transfers?
Ensure brevity in your answer.  2.87. What is the difference between the highest and the lowest Expenses (% of total expenses) in Other expenses?
Your answer should be very brief. 10.71. 